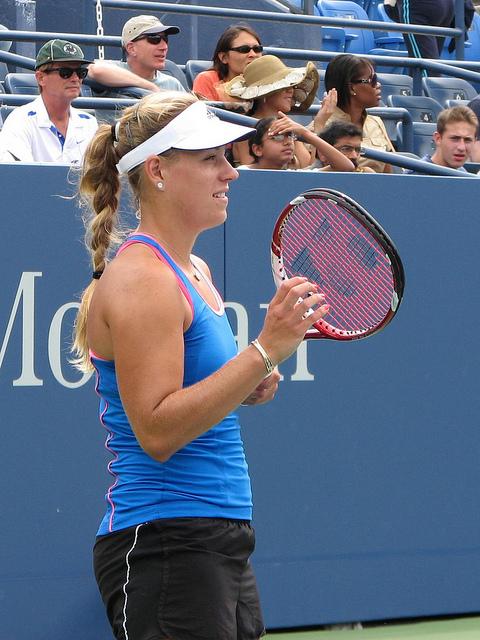What color is her sports bra?
Answer briefly. Pink. What color are the strings on her racket?
Keep it brief. Pink. What type of hat is the tennis player wearing?
Be succinct. Visor. 